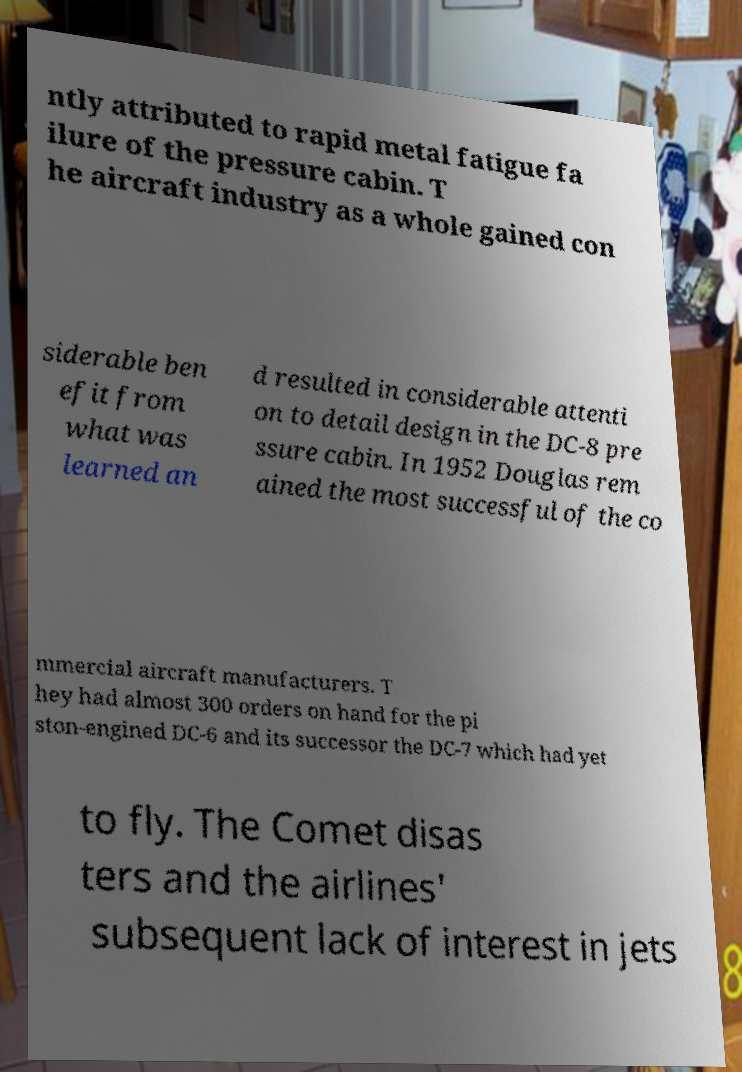Could you assist in decoding the text presented in this image and type it out clearly? ntly attributed to rapid metal fatigue fa ilure of the pressure cabin. T he aircraft industry as a whole gained con siderable ben efit from what was learned an d resulted in considerable attenti on to detail design in the DC-8 pre ssure cabin. In 1952 Douglas rem ained the most successful of the co mmercial aircraft manufacturers. T hey had almost 300 orders on hand for the pi ston-engined DC-6 and its successor the DC-7 which had yet to fly. The Comet disas ters and the airlines' subsequent lack of interest in jets 